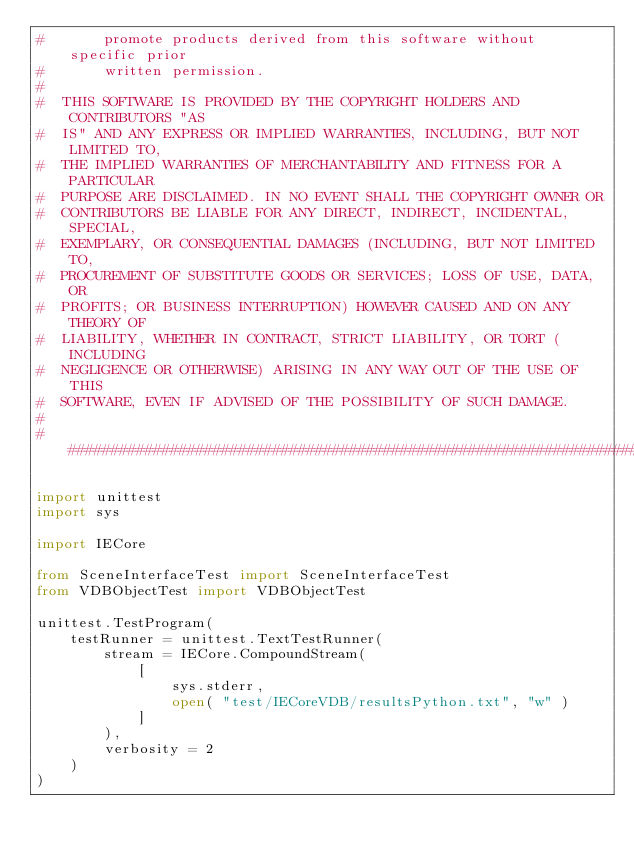<code> <loc_0><loc_0><loc_500><loc_500><_Python_>#       promote products derived from this software without specific prior
#       written permission.
#
#  THIS SOFTWARE IS PROVIDED BY THE COPYRIGHT HOLDERS AND CONTRIBUTORS "AS
#  IS" AND ANY EXPRESS OR IMPLIED WARRANTIES, INCLUDING, BUT NOT LIMITED TO,
#  THE IMPLIED WARRANTIES OF MERCHANTABILITY AND FITNESS FOR A PARTICULAR
#  PURPOSE ARE DISCLAIMED. IN NO EVENT SHALL THE COPYRIGHT OWNER OR
#  CONTRIBUTORS BE LIABLE FOR ANY DIRECT, INDIRECT, INCIDENTAL, SPECIAL,
#  EXEMPLARY, OR CONSEQUENTIAL DAMAGES (INCLUDING, BUT NOT LIMITED TO,
#  PROCUREMENT OF SUBSTITUTE GOODS OR SERVICES; LOSS OF USE, DATA, OR
#  PROFITS; OR BUSINESS INTERRUPTION) HOWEVER CAUSED AND ON ANY THEORY OF
#  LIABILITY, WHETHER IN CONTRACT, STRICT LIABILITY, OR TORT (INCLUDING
#  NEGLIGENCE OR OTHERWISE) ARISING IN ANY WAY OUT OF THE USE OF THIS
#  SOFTWARE, EVEN IF ADVISED OF THE POSSIBILITY OF SUCH DAMAGE.
#
##########################################################################

import unittest
import sys

import IECore

from SceneInterfaceTest import SceneInterfaceTest
from VDBObjectTest import VDBObjectTest

unittest.TestProgram(
	testRunner = unittest.TextTestRunner(
		stream = IECore.CompoundStream(
			[
				sys.stderr,
				open( "test/IECoreVDB/resultsPython.txt", "w" )
			]
		),
		verbosity = 2
	)
)
</code> 